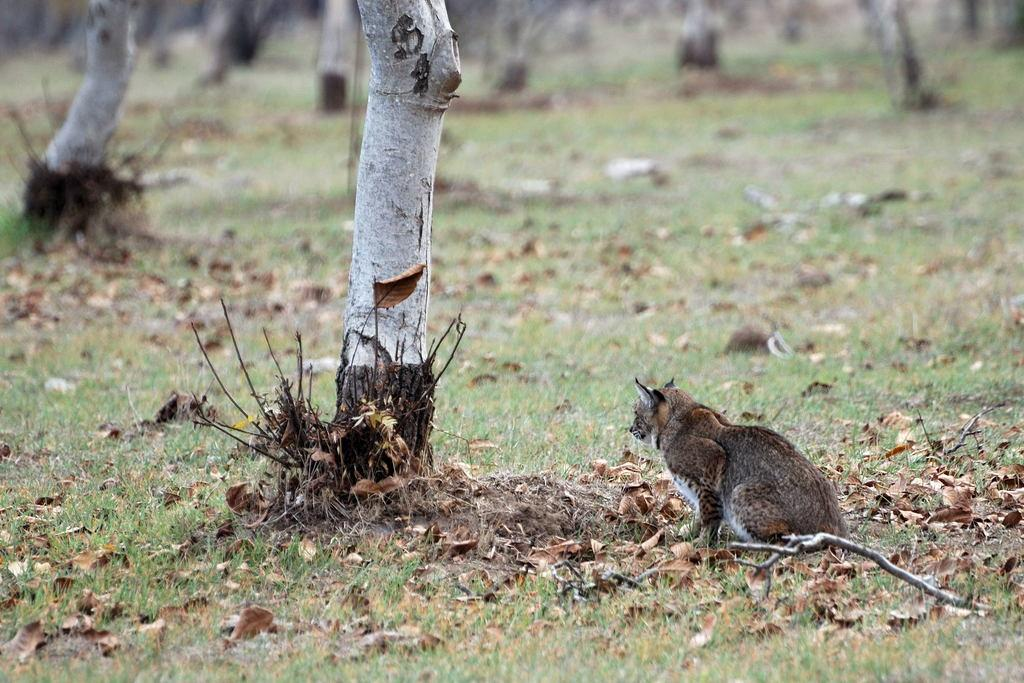What materials are present in the image? There are wood and leaves in the image. Can you describe the animal in the image? There is an animal on the ground in the image. What type of shoes is the beggar wearing in the image? There is no beggar present in the image, so it is impossible to determine the type of shoes they might be wearing. 